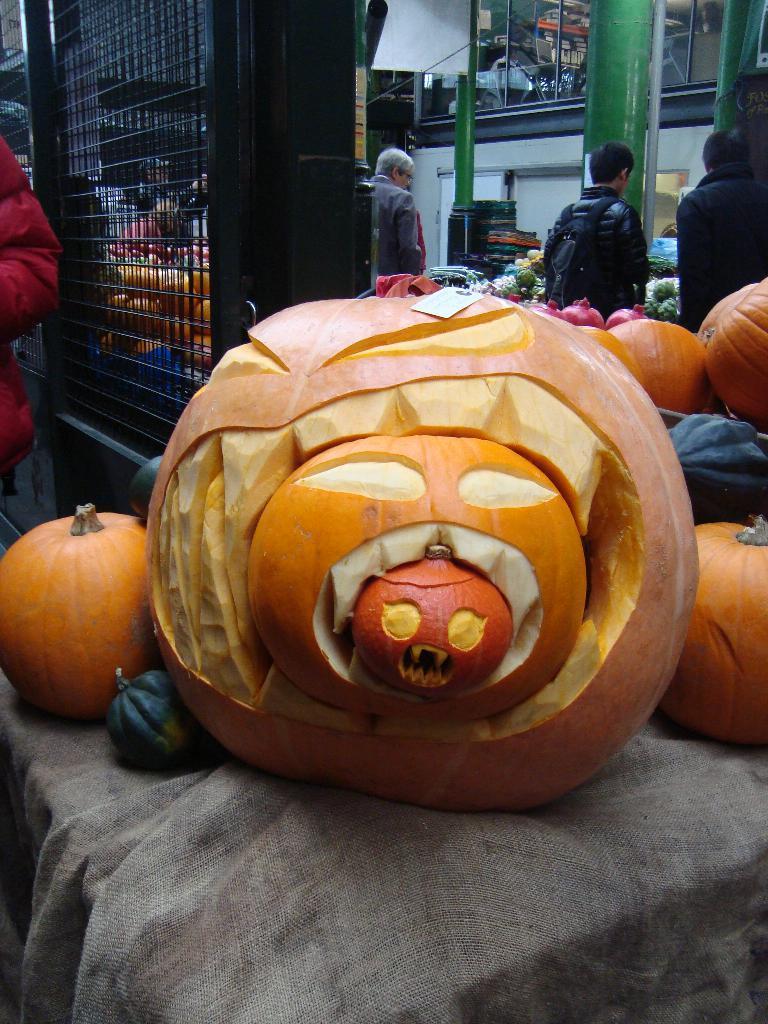Please provide a concise description of this image. In the center of the image we can see some pumpkins placed on the cloth. In the background we can see some persons standing in front of the vegetables. 